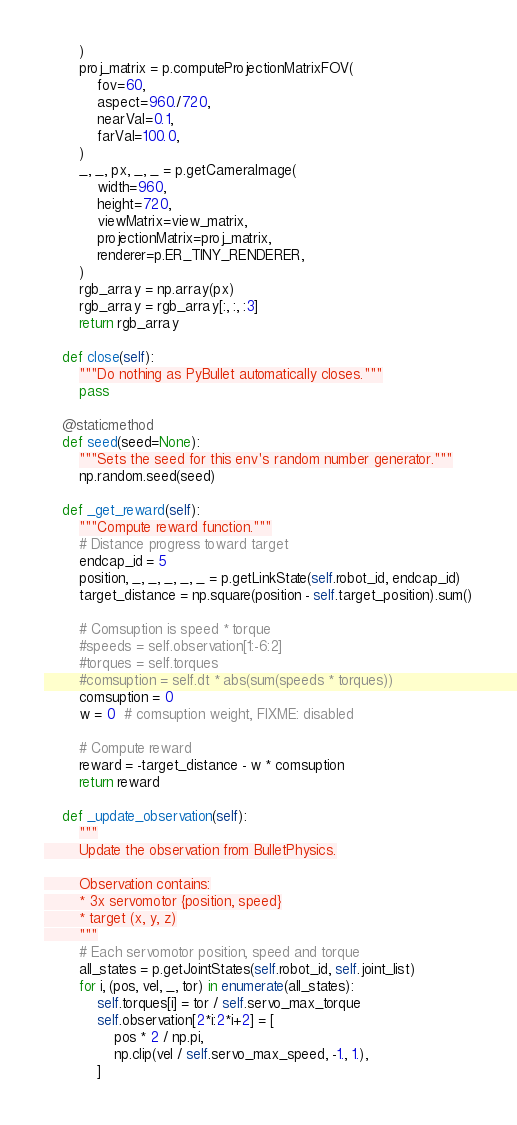Convert code to text. <code><loc_0><loc_0><loc_500><loc_500><_Python_>        )
        proj_matrix = p.computeProjectionMatrixFOV(
            fov=60,
            aspect=960./720,
            nearVal=0.1,
            farVal=100.0,
        )
        _, _, px, _, _ = p.getCameraImage(
            width=960,
            height=720,
            viewMatrix=view_matrix,
            projectionMatrix=proj_matrix,
            renderer=p.ER_TINY_RENDERER,
        )
        rgb_array = np.array(px)
        rgb_array = rgb_array[:, :, :3]
        return rgb_array

    def close(self):
        """Do nothing as PyBullet automatically closes."""
        pass

    @staticmethod
    def seed(seed=None):
        """Sets the seed for this env's random number generator."""
        np.random.seed(seed)

    def _get_reward(self):
        """Compute reward function."""
        # Distance progress toward target
        endcap_id = 5
        position, _, _, _, _, _ = p.getLinkState(self.robot_id, endcap_id)
        target_distance = np.square(position - self.target_position).sum()

        # Comsuption is speed * torque
        #speeds = self.observation[1:-6:2]
        #torques = self.torques
        #comsuption = self.dt * abs(sum(speeds * torques))
        comsuption = 0
        w = 0  # comsuption weight, FIXME: disabled

        # Compute reward
        reward = -target_distance - w * comsuption
        return reward

    def _update_observation(self):
        """
        Update the observation from BulletPhysics.

        Observation contains:
        * 3x servomotor {position, speed}
        * target (x, y, z)
        """
        # Each servomotor position, speed and torque
        all_states = p.getJointStates(self.robot_id, self.joint_list)
        for i, (pos, vel, _, tor) in enumerate(all_states):
            self.torques[i] = tor / self.servo_max_torque
            self.observation[2*i:2*i+2] = [
                pos * 2 / np.pi,
                np.clip(vel / self.servo_max_speed, -1., 1.),
            ]
</code> 